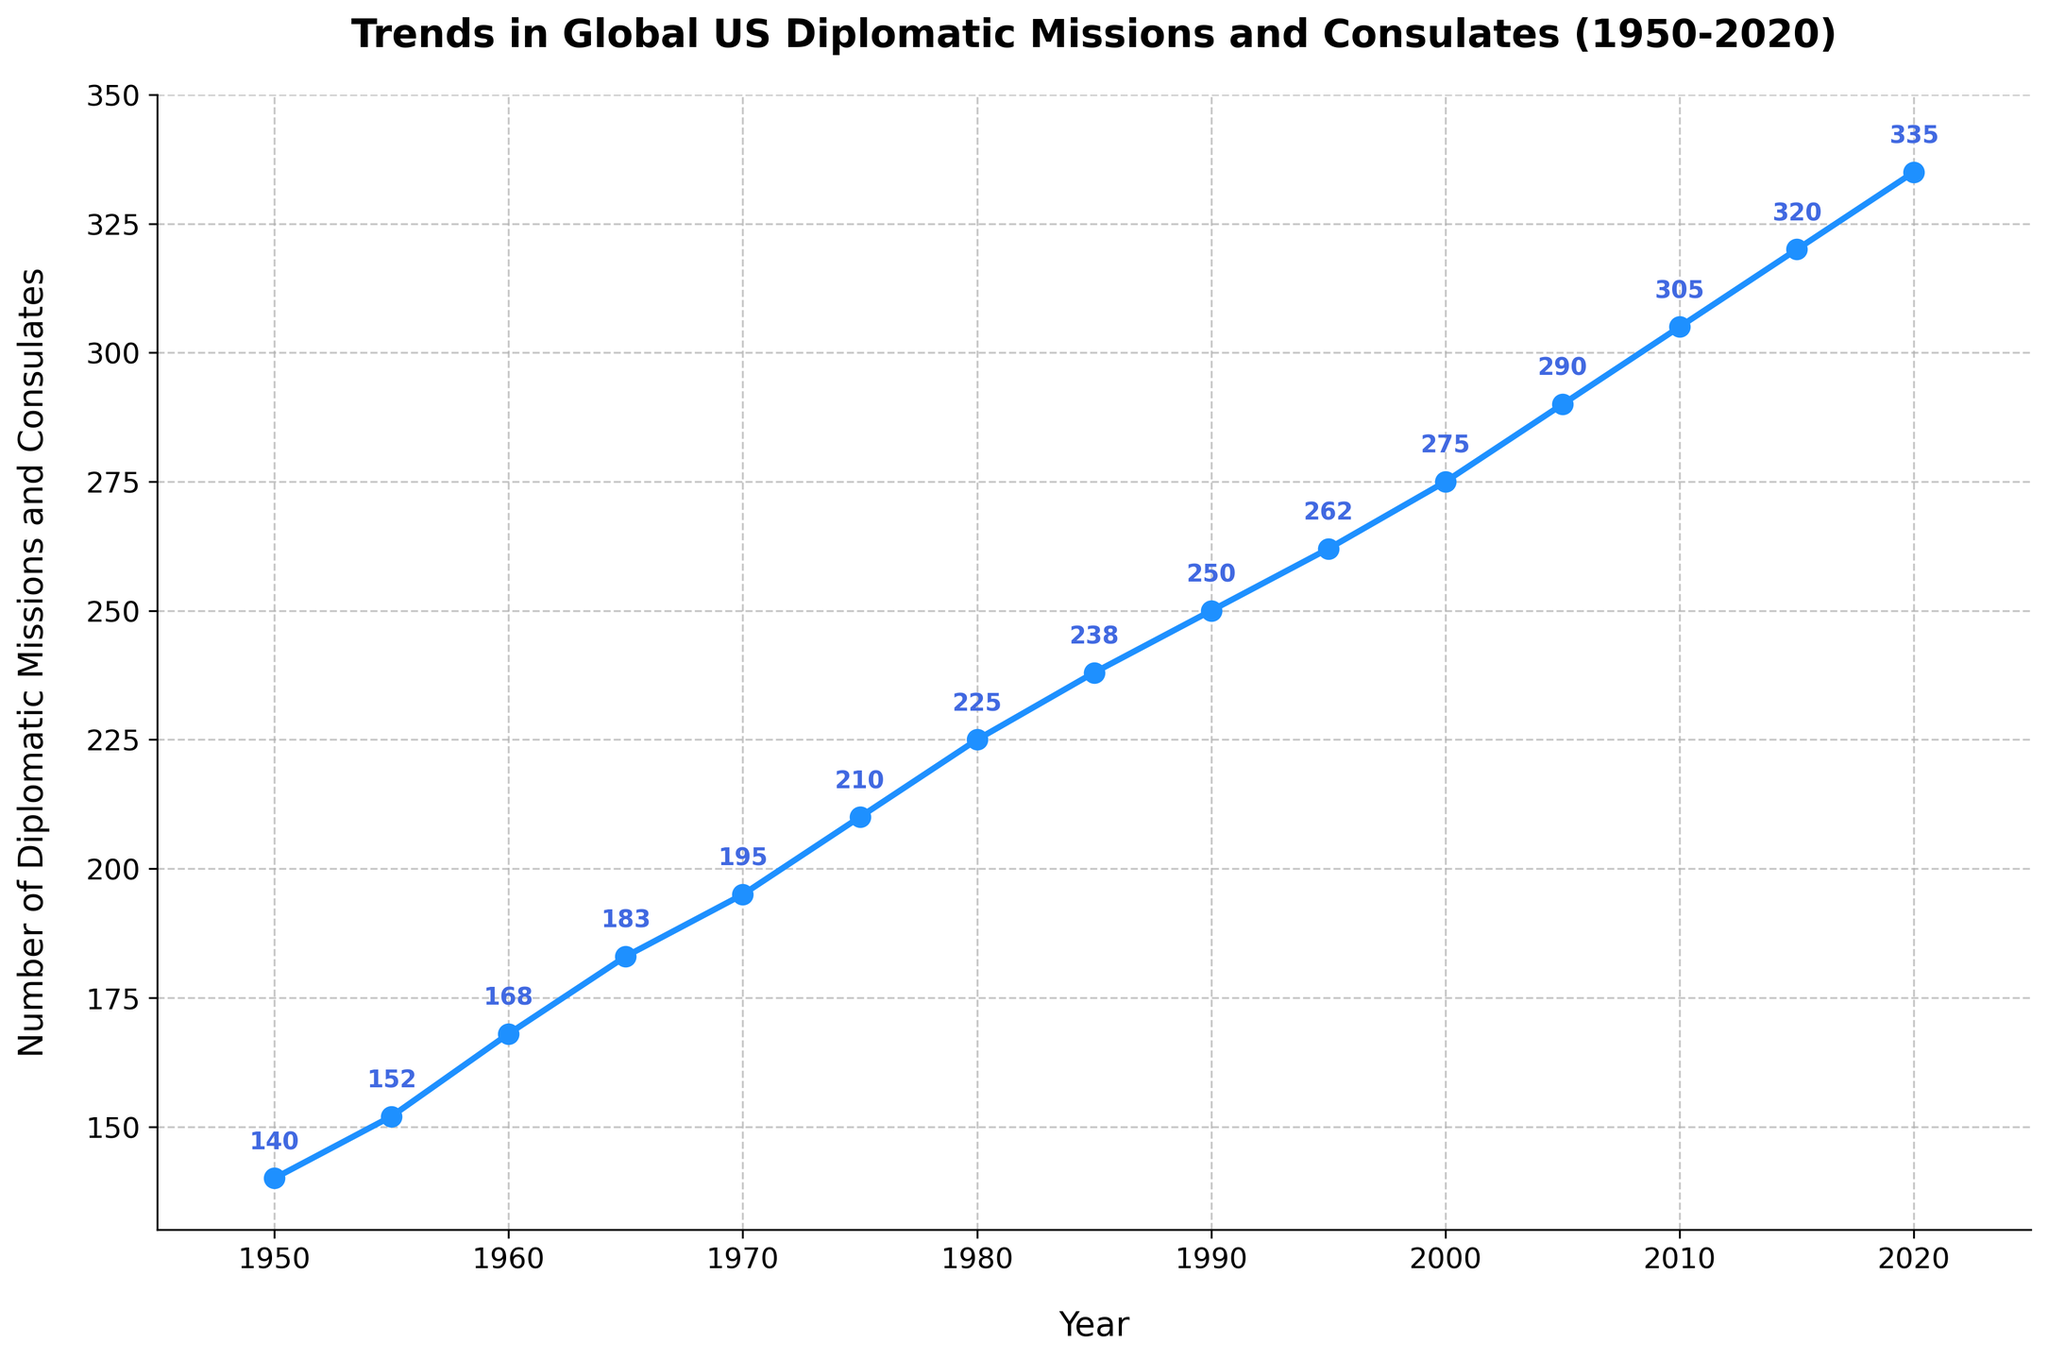What year shows the highest number of US diplomatic missions and consulates? To find the year with the highest number, check the peak point of the line. The highest y-value (335) occurs in 2020.
Answer: 2020 Between which years did the number of diplomatic missions and consulates experience the largest increase? Calculate the difference in the number of missions and consulates between consecutive periods and identify the largest change. The largest increase (30) is between 1950 (140) and 1955 (152).
Answer: 1950-1955 What is the average number of diplomatic missions and consulates from 1950 to 2020? Sum all the values (140+152+168+183+195+210+225+238+250+262+275+290+305+320+335 = 3348) and divide by the number of data points (15). So, the average is 3348 / 15.
Answer: 223.2 How many more diplomatic missions and consulates were there in 2020 compared to 1950? Subtract the number in 1950 (140) from the number in 2020 (335). The difference is 335 - 140.
Answer: 195 During which decade did the number of diplomatic missions and consulates first surpass 200? Look for the first year where the y-value is greater than 200. In 1975, the number reached 210. The decade is the 1970s.
Answer: 1970s Which decade had the slowest growth in the number of diplomatic missions and consulates? Calculate the increase in each decade and find the smallest. From 1980 to 1990 (225 to 250), the increase is 25, which is slower compared to other decades.
Answer: 1980s What were the trends in the number of diplomatic missions and consulates from 2000 to 2010? From 2000 (275) to 2010 (305), there is a consistent increase. Subtracting 2000 from 2010 provides the increase: 305 - 275 = 30.
Answer: Consistently increasing How much did the number of diplomatic missions and consulates increase during the 1950s? Subtract the value in 1950 (140) from the value in 1960 (168). The increase is 168 - 140.
Answer: 28 By how many missions did the number of diplomatic missions and consulates grow in total from 1950 to 2020? Subtract the starting value in 1950 (140) from the final value in 2020 (335). The overall increase is 335 - 140.
Answer: 195 What visual style is used for the line representing the number of diplomatic missions and consulates? The line has markers ('o'), a solid linestyle ('-'), and the color blue.
Answer: Blue line with 'o' markers 